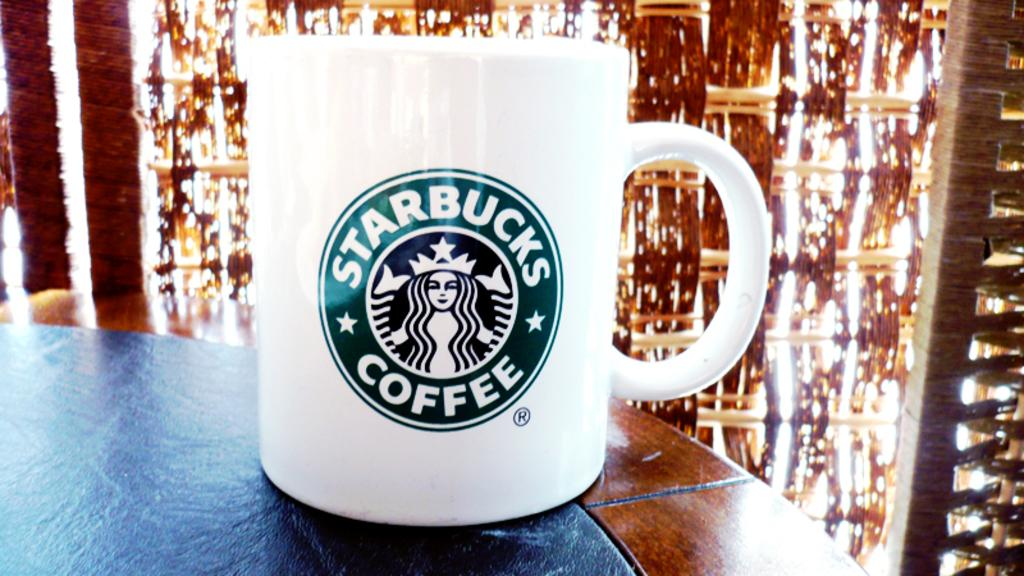<image>
Share a concise interpretation of the image provided. A coffee cup labeled Starbucks Coffee is sitting on a counter. 